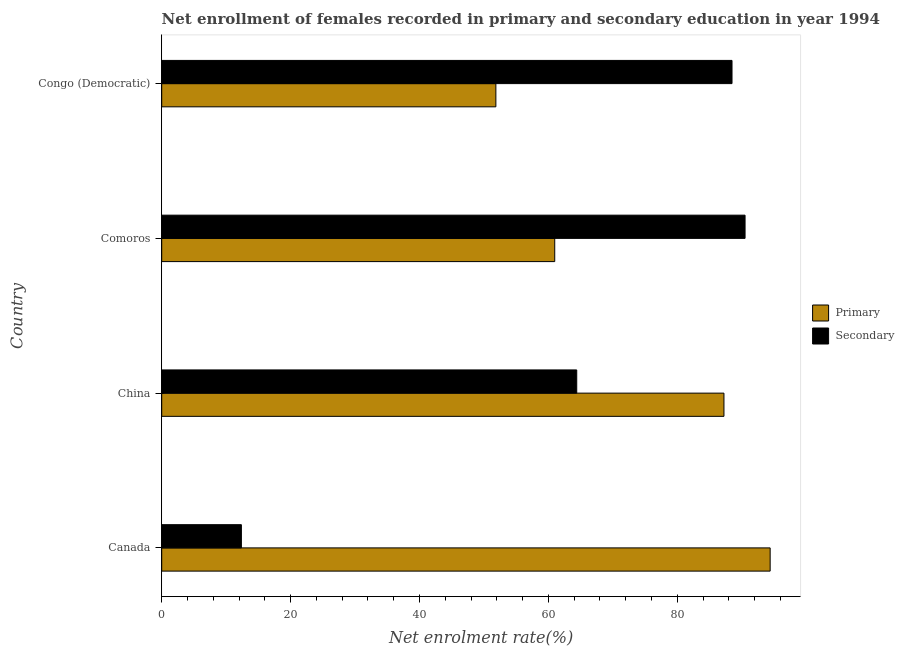How many different coloured bars are there?
Ensure brevity in your answer.  2. How many groups of bars are there?
Provide a succinct answer. 4. Are the number of bars per tick equal to the number of legend labels?
Your answer should be very brief. Yes. Are the number of bars on each tick of the Y-axis equal?
Offer a very short reply. Yes. What is the enrollment rate in secondary education in Congo (Democratic)?
Your answer should be compact. 88.49. Across all countries, what is the maximum enrollment rate in primary education?
Your answer should be compact. 94.41. Across all countries, what is the minimum enrollment rate in primary education?
Offer a very short reply. 51.85. In which country was the enrollment rate in secondary education maximum?
Your answer should be compact. Comoros. In which country was the enrollment rate in primary education minimum?
Your response must be concise. Congo (Democratic). What is the total enrollment rate in primary education in the graph?
Make the answer very short. 294.49. What is the difference between the enrollment rate in secondary education in China and that in Congo (Democratic)?
Your answer should be very brief. -24.09. What is the difference between the enrollment rate in secondary education in China and the enrollment rate in primary education in Congo (Democratic)?
Provide a short and direct response. 12.55. What is the average enrollment rate in primary education per country?
Your response must be concise. 73.62. What is the difference between the enrollment rate in primary education and enrollment rate in secondary education in Congo (Democratic)?
Ensure brevity in your answer.  -36.64. What is the ratio of the enrollment rate in primary education in Comoros to that in Congo (Democratic)?
Your response must be concise. 1.18. What is the difference between the highest and the second highest enrollment rate in secondary education?
Give a very brief answer. 2.02. What is the difference between the highest and the lowest enrollment rate in primary education?
Offer a terse response. 42.56. Is the sum of the enrollment rate in primary education in China and Congo (Democratic) greater than the maximum enrollment rate in secondary education across all countries?
Offer a terse response. Yes. What does the 2nd bar from the top in Canada represents?
Provide a succinct answer. Primary. What does the 1st bar from the bottom in Comoros represents?
Give a very brief answer. Primary. How many bars are there?
Give a very brief answer. 8. Are all the bars in the graph horizontal?
Give a very brief answer. Yes. What is the difference between two consecutive major ticks on the X-axis?
Your answer should be very brief. 20. Are the values on the major ticks of X-axis written in scientific E-notation?
Provide a short and direct response. No. Does the graph contain grids?
Provide a short and direct response. No. How are the legend labels stacked?
Make the answer very short. Vertical. What is the title of the graph?
Your answer should be very brief. Net enrollment of females recorded in primary and secondary education in year 1994. Does "By country of asylum" appear as one of the legend labels in the graph?
Give a very brief answer. No. What is the label or title of the X-axis?
Your response must be concise. Net enrolment rate(%). What is the label or title of the Y-axis?
Offer a very short reply. Country. What is the Net enrolment rate(%) in Primary in Canada?
Ensure brevity in your answer.  94.41. What is the Net enrolment rate(%) of Secondary in Canada?
Make the answer very short. 12.36. What is the Net enrolment rate(%) in Primary in China?
Your answer should be compact. 87.24. What is the Net enrolment rate(%) in Secondary in China?
Offer a terse response. 64.4. What is the Net enrolment rate(%) in Primary in Comoros?
Offer a very short reply. 60.98. What is the Net enrolment rate(%) in Secondary in Comoros?
Make the answer very short. 90.52. What is the Net enrolment rate(%) of Primary in Congo (Democratic)?
Keep it short and to the point. 51.85. What is the Net enrolment rate(%) in Secondary in Congo (Democratic)?
Offer a terse response. 88.49. Across all countries, what is the maximum Net enrolment rate(%) of Primary?
Your answer should be compact. 94.41. Across all countries, what is the maximum Net enrolment rate(%) of Secondary?
Ensure brevity in your answer.  90.52. Across all countries, what is the minimum Net enrolment rate(%) in Primary?
Your answer should be compact. 51.85. Across all countries, what is the minimum Net enrolment rate(%) of Secondary?
Offer a terse response. 12.36. What is the total Net enrolment rate(%) of Primary in the graph?
Provide a short and direct response. 294.49. What is the total Net enrolment rate(%) in Secondary in the graph?
Offer a very short reply. 255.78. What is the difference between the Net enrolment rate(%) of Primary in Canada and that in China?
Give a very brief answer. 7.17. What is the difference between the Net enrolment rate(%) of Secondary in Canada and that in China?
Your response must be concise. -52.04. What is the difference between the Net enrolment rate(%) of Primary in Canada and that in Comoros?
Offer a very short reply. 33.43. What is the difference between the Net enrolment rate(%) in Secondary in Canada and that in Comoros?
Your answer should be very brief. -78.16. What is the difference between the Net enrolment rate(%) of Primary in Canada and that in Congo (Democratic)?
Offer a terse response. 42.56. What is the difference between the Net enrolment rate(%) of Secondary in Canada and that in Congo (Democratic)?
Make the answer very short. -76.13. What is the difference between the Net enrolment rate(%) in Primary in China and that in Comoros?
Make the answer very short. 26.26. What is the difference between the Net enrolment rate(%) of Secondary in China and that in Comoros?
Offer a terse response. -26.12. What is the difference between the Net enrolment rate(%) of Primary in China and that in Congo (Democratic)?
Give a very brief answer. 35.39. What is the difference between the Net enrolment rate(%) in Secondary in China and that in Congo (Democratic)?
Provide a short and direct response. -24.09. What is the difference between the Net enrolment rate(%) in Primary in Comoros and that in Congo (Democratic)?
Offer a very short reply. 9.13. What is the difference between the Net enrolment rate(%) in Secondary in Comoros and that in Congo (Democratic)?
Your answer should be compact. 2.03. What is the difference between the Net enrolment rate(%) in Primary in Canada and the Net enrolment rate(%) in Secondary in China?
Give a very brief answer. 30.01. What is the difference between the Net enrolment rate(%) in Primary in Canada and the Net enrolment rate(%) in Secondary in Comoros?
Keep it short and to the point. 3.89. What is the difference between the Net enrolment rate(%) of Primary in Canada and the Net enrolment rate(%) of Secondary in Congo (Democratic)?
Your response must be concise. 5.92. What is the difference between the Net enrolment rate(%) of Primary in China and the Net enrolment rate(%) of Secondary in Comoros?
Your answer should be compact. -3.28. What is the difference between the Net enrolment rate(%) in Primary in China and the Net enrolment rate(%) in Secondary in Congo (Democratic)?
Give a very brief answer. -1.25. What is the difference between the Net enrolment rate(%) of Primary in Comoros and the Net enrolment rate(%) of Secondary in Congo (Democratic)?
Provide a short and direct response. -27.51. What is the average Net enrolment rate(%) of Primary per country?
Ensure brevity in your answer.  73.62. What is the average Net enrolment rate(%) of Secondary per country?
Your answer should be compact. 63.94. What is the difference between the Net enrolment rate(%) of Primary and Net enrolment rate(%) of Secondary in Canada?
Make the answer very short. 82.05. What is the difference between the Net enrolment rate(%) in Primary and Net enrolment rate(%) in Secondary in China?
Ensure brevity in your answer.  22.84. What is the difference between the Net enrolment rate(%) in Primary and Net enrolment rate(%) in Secondary in Comoros?
Offer a very short reply. -29.53. What is the difference between the Net enrolment rate(%) of Primary and Net enrolment rate(%) of Secondary in Congo (Democratic)?
Your response must be concise. -36.64. What is the ratio of the Net enrolment rate(%) in Primary in Canada to that in China?
Offer a very short reply. 1.08. What is the ratio of the Net enrolment rate(%) of Secondary in Canada to that in China?
Your answer should be compact. 0.19. What is the ratio of the Net enrolment rate(%) of Primary in Canada to that in Comoros?
Provide a succinct answer. 1.55. What is the ratio of the Net enrolment rate(%) in Secondary in Canada to that in Comoros?
Offer a very short reply. 0.14. What is the ratio of the Net enrolment rate(%) in Primary in Canada to that in Congo (Democratic)?
Your response must be concise. 1.82. What is the ratio of the Net enrolment rate(%) in Secondary in Canada to that in Congo (Democratic)?
Give a very brief answer. 0.14. What is the ratio of the Net enrolment rate(%) of Primary in China to that in Comoros?
Your answer should be compact. 1.43. What is the ratio of the Net enrolment rate(%) of Secondary in China to that in Comoros?
Your response must be concise. 0.71. What is the ratio of the Net enrolment rate(%) in Primary in China to that in Congo (Democratic)?
Provide a short and direct response. 1.68. What is the ratio of the Net enrolment rate(%) of Secondary in China to that in Congo (Democratic)?
Give a very brief answer. 0.73. What is the ratio of the Net enrolment rate(%) of Primary in Comoros to that in Congo (Democratic)?
Your response must be concise. 1.18. What is the ratio of the Net enrolment rate(%) of Secondary in Comoros to that in Congo (Democratic)?
Your answer should be compact. 1.02. What is the difference between the highest and the second highest Net enrolment rate(%) of Primary?
Your answer should be compact. 7.17. What is the difference between the highest and the second highest Net enrolment rate(%) of Secondary?
Make the answer very short. 2.03. What is the difference between the highest and the lowest Net enrolment rate(%) in Primary?
Ensure brevity in your answer.  42.56. What is the difference between the highest and the lowest Net enrolment rate(%) of Secondary?
Your response must be concise. 78.16. 